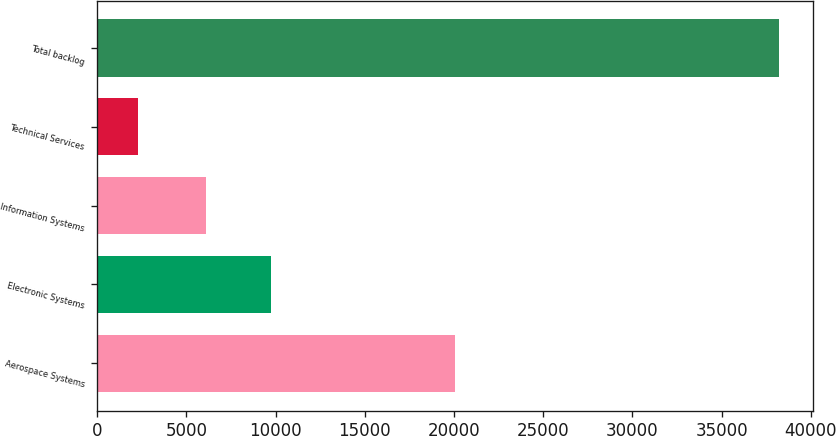Convert chart. <chart><loc_0><loc_0><loc_500><loc_500><bar_chart><fcel>Aerospace Systems<fcel>Electronic Systems<fcel>Information Systems<fcel>Technical Services<fcel>Total backlog<nl><fcel>20063<fcel>9715<fcel>6115<fcel>2306<fcel>38199<nl></chart> 